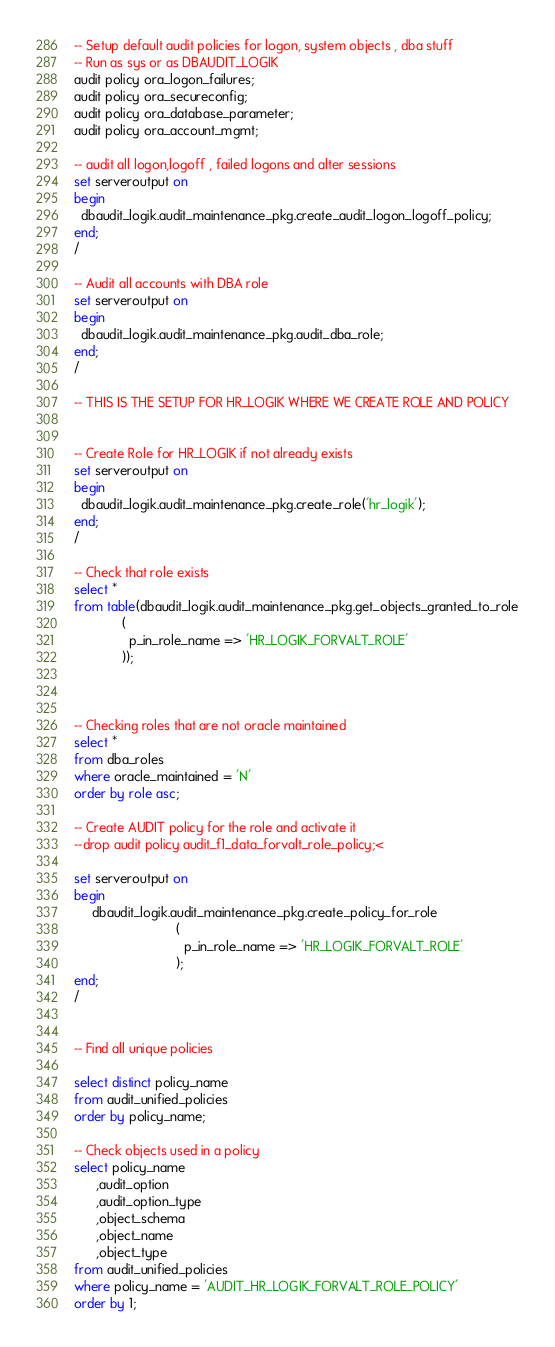Convert code to text. <code><loc_0><loc_0><loc_500><loc_500><_SQL_>-- Setup default audit policies for logon, system objects , dba stuff
-- Run as sys or as DBAUDIT_LOGIK
audit policy ora_logon_failures;
audit policy ora_secureconfig;
audit policy ora_database_parameter;
audit policy ora_account_mgmt;

-- audit all logon,logoff , failed logons and alter sessions
set serveroutput on
begin
  dbaudit_logik.audit_maintenance_pkg.create_audit_logon_logoff_policy;
end;
/

-- Audit all accounts with DBA role
set serveroutput on
begin
  dbaudit_logik.audit_maintenance_pkg.audit_dba_role;
end;
/

-- THIS IS THE SETUP FOR HR_LOGIK WHERE WE CREATE ROLE AND POLICY


-- Create Role for HR_LOGIK if not already exists
set serveroutput on 
begin
  dbaudit_logik.audit_maintenance_pkg.create_role('hr_logik');
end;
/

-- Check that role exists
select *
from table(dbaudit_logik.audit_maintenance_pkg.get_objects_granted_to_role
             (
               p_in_role_name => 'HR_LOGIK_FORVALT_ROLE'
             ));



-- Checking roles that are not oracle maintained
select *
from dba_roles
where oracle_maintained = 'N'
order by role asc;

-- Create AUDIT policy for the role and activate it
--drop audit policy audit_f1_data_forvalt_role_policy;<

set serveroutput on
begin
     dbaudit_logik.audit_maintenance_pkg.create_policy_for_role
                            (
                              p_in_role_name => 'HR_LOGIK_FORVALT_ROLE'
                            );
end;
/


-- Find all unique policies

select distinct policy_name 
from audit_unified_policies
order by policy_name;

-- Check objects used in a policy
select policy_name
      ,audit_option
      ,audit_option_type
      ,object_schema
      ,object_name
      ,object_type
from audit_unified_policies
where policy_name = 'AUDIT_HR_LOGIK_FORVALT_ROLE_POLICY'
order by 1;


</code> 